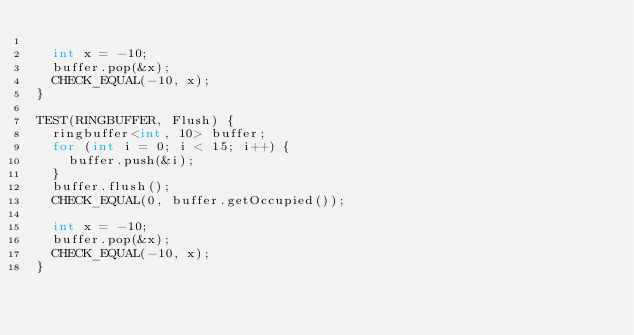Convert code to text. <code><loc_0><loc_0><loc_500><loc_500><_C++_>
  int x = -10;
  buffer.pop(&x);
  CHECK_EQUAL(-10, x);
}

TEST(RINGBUFFER, Flush) {
  ringbuffer<int, 10> buffer;
  for (int i = 0; i < 15; i++) {
    buffer.push(&i);
  }
  buffer.flush();
  CHECK_EQUAL(0, buffer.getOccupied());

  int x = -10;
  buffer.pop(&x);
  CHECK_EQUAL(-10, x);
}
</code> 